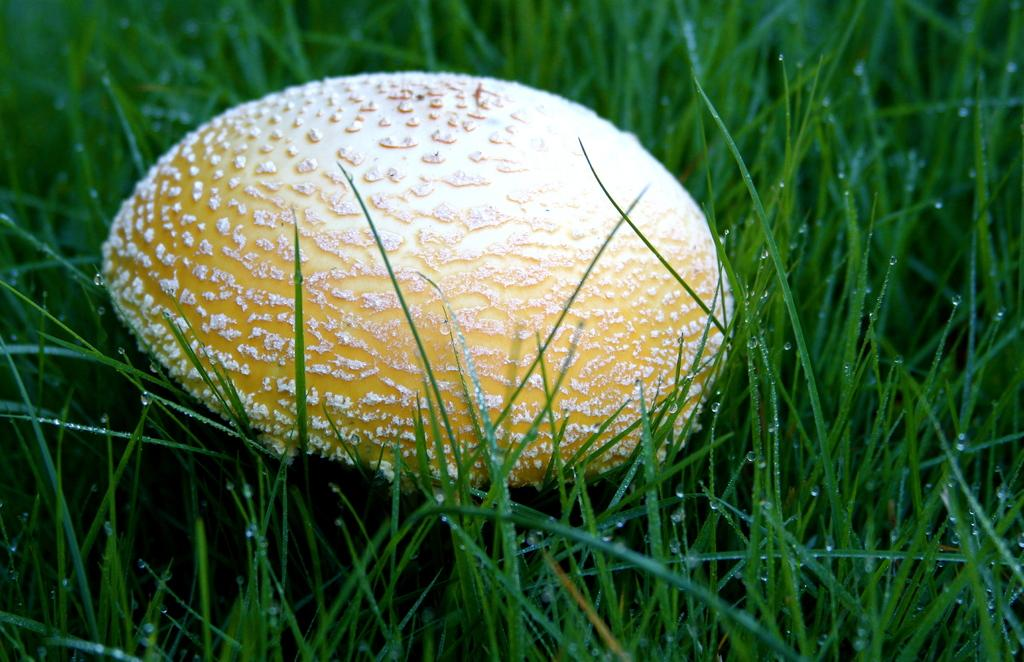What type of plant is visible in the image? There is a mushroom in the image. What other type of plant can be seen in the image? There are grasses in the image. What is the condition of the grasses in the image? The grasses have water drops on them. What type of fang can be seen on the mushroom in the image? There are no fangs present on the mushroom in the image. What decision is the mushroom making in the image? The mushroom is not making any decisions in the image, as it is an inanimate object. 